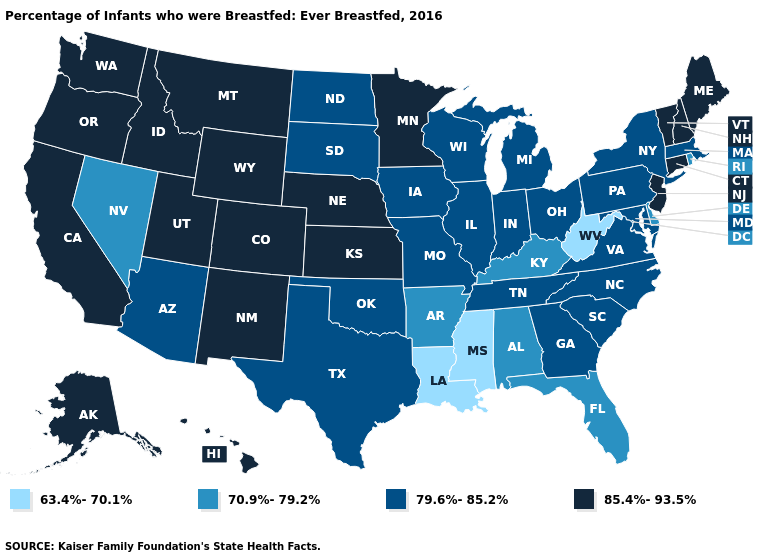Among the states that border Arkansas , does Mississippi have the lowest value?
Give a very brief answer. Yes. What is the lowest value in states that border Massachusetts?
Answer briefly. 70.9%-79.2%. Which states hav the highest value in the MidWest?
Concise answer only. Kansas, Minnesota, Nebraska. Name the states that have a value in the range 63.4%-70.1%?
Keep it brief. Louisiana, Mississippi, West Virginia. Name the states that have a value in the range 79.6%-85.2%?
Keep it brief. Arizona, Georgia, Illinois, Indiana, Iowa, Maryland, Massachusetts, Michigan, Missouri, New York, North Carolina, North Dakota, Ohio, Oklahoma, Pennsylvania, South Carolina, South Dakota, Tennessee, Texas, Virginia, Wisconsin. What is the value of Wyoming?
Be succinct. 85.4%-93.5%. Name the states that have a value in the range 70.9%-79.2%?
Keep it brief. Alabama, Arkansas, Delaware, Florida, Kentucky, Nevada, Rhode Island. What is the value of Minnesota?
Write a very short answer. 85.4%-93.5%. What is the value of Arkansas?
Be succinct. 70.9%-79.2%. Name the states that have a value in the range 70.9%-79.2%?
Give a very brief answer. Alabama, Arkansas, Delaware, Florida, Kentucky, Nevada, Rhode Island. Does Arkansas have a lower value than Virginia?
Short answer required. Yes. Among the states that border Texas , which have the highest value?
Be succinct. New Mexico. What is the value of Maryland?
Write a very short answer. 79.6%-85.2%. Name the states that have a value in the range 79.6%-85.2%?
Concise answer only. Arizona, Georgia, Illinois, Indiana, Iowa, Maryland, Massachusetts, Michigan, Missouri, New York, North Carolina, North Dakota, Ohio, Oklahoma, Pennsylvania, South Carolina, South Dakota, Tennessee, Texas, Virginia, Wisconsin. What is the value of Missouri?
Be succinct. 79.6%-85.2%. 